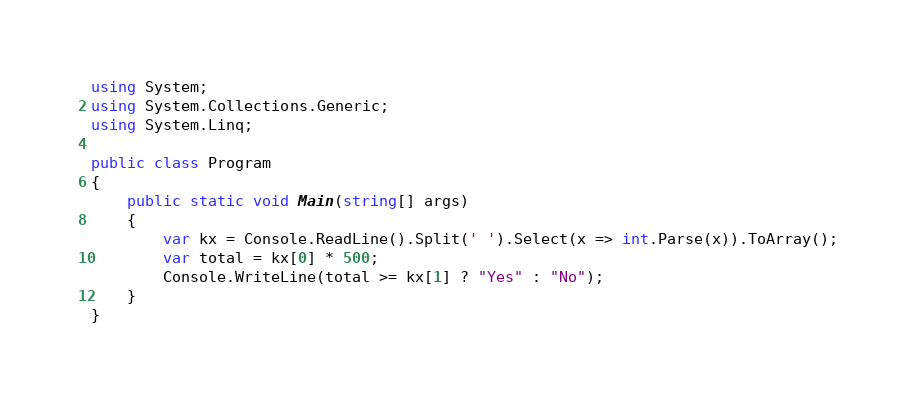<code> <loc_0><loc_0><loc_500><loc_500><_C#_>using System;
using System.Collections.Generic;
using System.Linq;

public class Program
{
    public static void Main(string[] args)
    {
        var kx = Console.ReadLine().Split(' ').Select(x => int.Parse(x)).ToArray();
        var total = kx[0] * 500;
        Console.WriteLine(total >= kx[1] ? "Yes" : "No");
    }
}</code> 